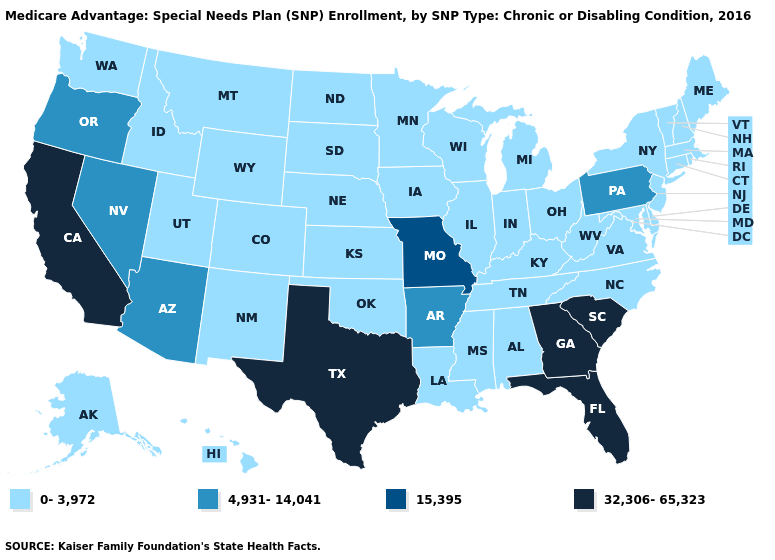Is the legend a continuous bar?
Keep it brief. No. Name the states that have a value in the range 32,306-65,323?
Concise answer only. California, Florida, Georgia, South Carolina, Texas. Name the states that have a value in the range 15,395?
Keep it brief. Missouri. What is the lowest value in the USA?
Keep it brief. 0-3,972. What is the highest value in the West ?
Short answer required. 32,306-65,323. Which states have the highest value in the USA?
Be succinct. California, Florida, Georgia, South Carolina, Texas. What is the value of New Mexico?
Concise answer only. 0-3,972. What is the value of Georgia?
Short answer required. 32,306-65,323. Does Maine have the lowest value in the Northeast?
Quick response, please. Yes. What is the value of Hawaii?
Answer briefly. 0-3,972. Name the states that have a value in the range 0-3,972?
Short answer required. Alaska, Alabama, Colorado, Connecticut, Delaware, Hawaii, Iowa, Idaho, Illinois, Indiana, Kansas, Kentucky, Louisiana, Massachusetts, Maryland, Maine, Michigan, Minnesota, Mississippi, Montana, North Carolina, North Dakota, Nebraska, New Hampshire, New Jersey, New Mexico, New York, Ohio, Oklahoma, Rhode Island, South Dakota, Tennessee, Utah, Virginia, Vermont, Washington, Wisconsin, West Virginia, Wyoming. Which states have the lowest value in the USA?
Give a very brief answer. Alaska, Alabama, Colorado, Connecticut, Delaware, Hawaii, Iowa, Idaho, Illinois, Indiana, Kansas, Kentucky, Louisiana, Massachusetts, Maryland, Maine, Michigan, Minnesota, Mississippi, Montana, North Carolina, North Dakota, Nebraska, New Hampshire, New Jersey, New Mexico, New York, Ohio, Oklahoma, Rhode Island, South Dakota, Tennessee, Utah, Virginia, Vermont, Washington, Wisconsin, West Virginia, Wyoming. What is the lowest value in states that border Maine?
Write a very short answer. 0-3,972. Name the states that have a value in the range 32,306-65,323?
Concise answer only. California, Florida, Georgia, South Carolina, Texas. 